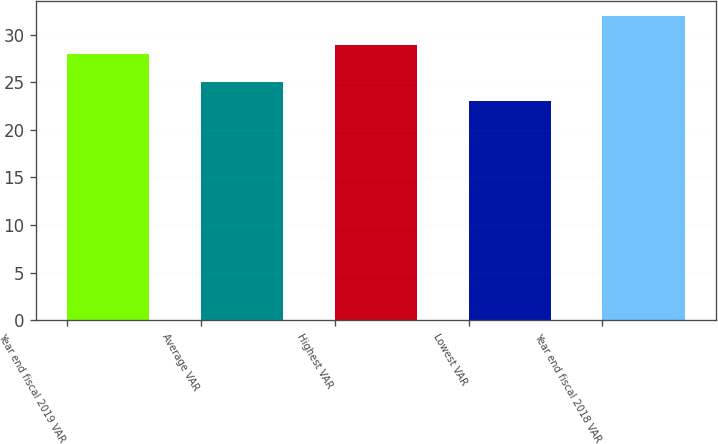Convert chart. <chart><loc_0><loc_0><loc_500><loc_500><bar_chart><fcel>Year end fiscal 2019 VAR<fcel>Average VAR<fcel>Highest VAR<fcel>Lowest VAR<fcel>Year end fiscal 2018 VAR<nl><fcel>28<fcel>25<fcel>28.9<fcel>23<fcel>32<nl></chart> 